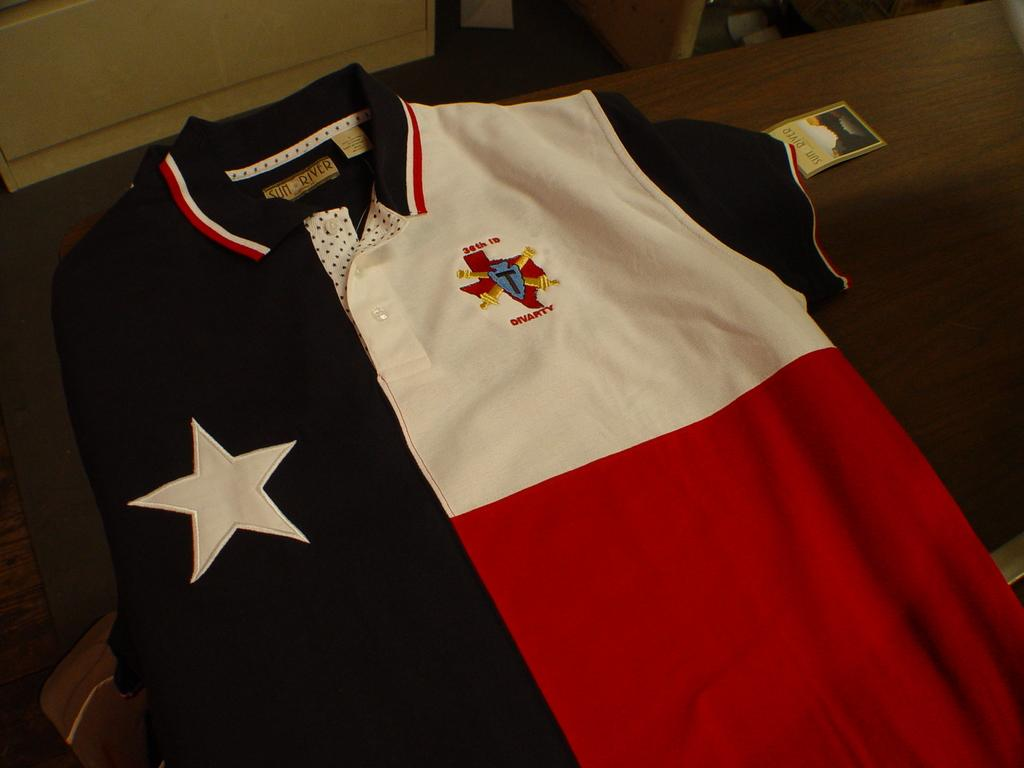What item is present on the table in the image? There is a t-shirt on the table in the image. What colors are present on the t-shirt? The t-shirt has blue, white, and red colors. Is there any additional information about the t-shirt? Yes, there is a tag on the t-shirt. What type of beast can be seen hiding in the cellar in the image? There is no beast or cellar present in the image; it only features a t-shirt on a table. 